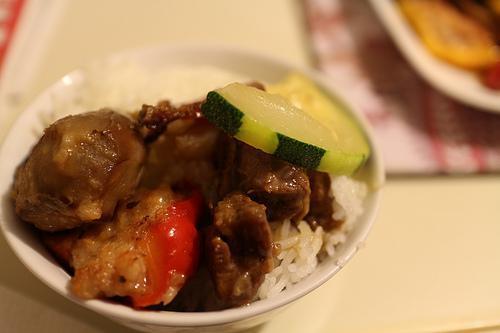How many bowls are there?
Give a very brief answer. 1. 